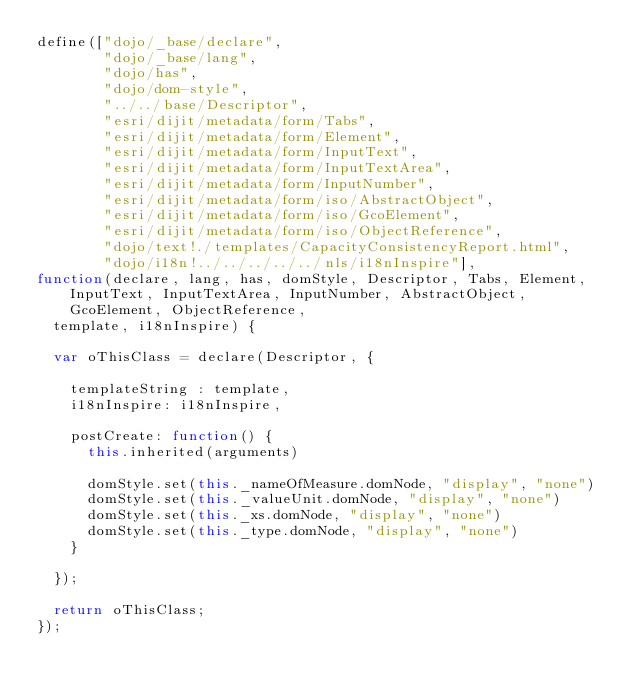<code> <loc_0><loc_0><loc_500><loc_500><_JavaScript_>define(["dojo/_base/declare",
        "dojo/_base/lang",
        "dojo/has",
        "dojo/dom-style",
        "../../base/Descriptor",
        "esri/dijit/metadata/form/Tabs",
        "esri/dijit/metadata/form/Element",
        "esri/dijit/metadata/form/InputText",
        "esri/dijit/metadata/form/InputTextArea",
        "esri/dijit/metadata/form/InputNumber",
        "esri/dijit/metadata/form/iso/AbstractObject",
        "esri/dijit/metadata/form/iso/GcoElement",
        "esri/dijit/metadata/form/iso/ObjectReference",
        "dojo/text!./templates/CapacityConsistencyReport.html",
        "dojo/i18n!../../../../../nls/i18nInspire"],
function(declare, lang, has, domStyle, Descriptor, Tabs, Element, InputText, InputTextArea, InputNumber, AbstractObject, GcoElement, ObjectReference,
  template, i18nInspire) {

  var oThisClass = declare(Descriptor, {

    templateString : template,
    i18nInspire: i18nInspire,
    
    postCreate: function() {
      this.inherited(arguments)
      
      domStyle.set(this._nameOfMeasure.domNode, "display", "none")
      domStyle.set(this._valueUnit.domNode, "display", "none")
      domStyle.set(this._xs.domNode, "display", "none")
      domStyle.set(this._type.domNode, "display", "none")
    }

  });

  return oThisClass;
});</code> 